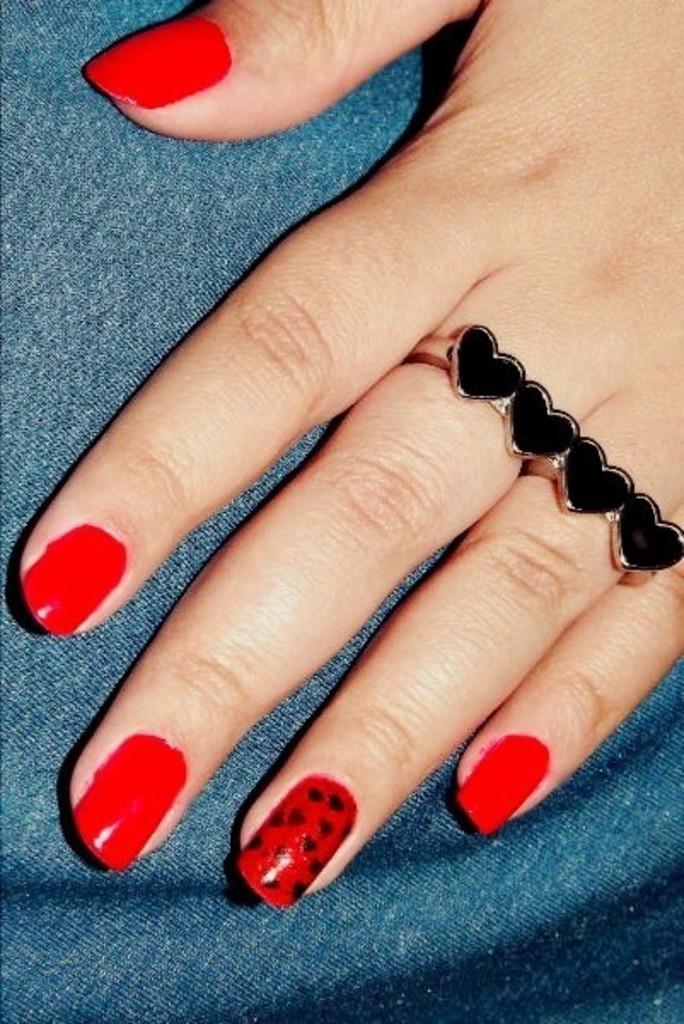Describe this image in one or two sentences. In the image we can see a human hand and there is a finger ring, in the fingers. This is a cloth, and the nail polish on the finger, the nail polish is red in color. 